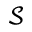Convert formula to latex. <formula><loc_0><loc_0><loc_500><loc_500>\mathcal { S }</formula> 